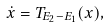<formula> <loc_0><loc_0><loc_500><loc_500>\dot { x } = T _ { E _ { 2 } - E _ { 1 } } ( x ) ,</formula> 